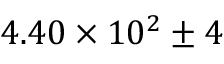Convert formula to latex. <formula><loc_0><loc_0><loc_500><loc_500>4 . 4 0 \times 1 0 ^ { 2 } \pm 4</formula> 